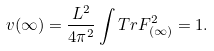Convert formula to latex. <formula><loc_0><loc_0><loc_500><loc_500>v ( \infty ) = \frac { L ^ { 2 } } { 4 \pi ^ { 2 } } \int T r F _ { ( \infty ) } ^ { 2 } = 1 .</formula> 